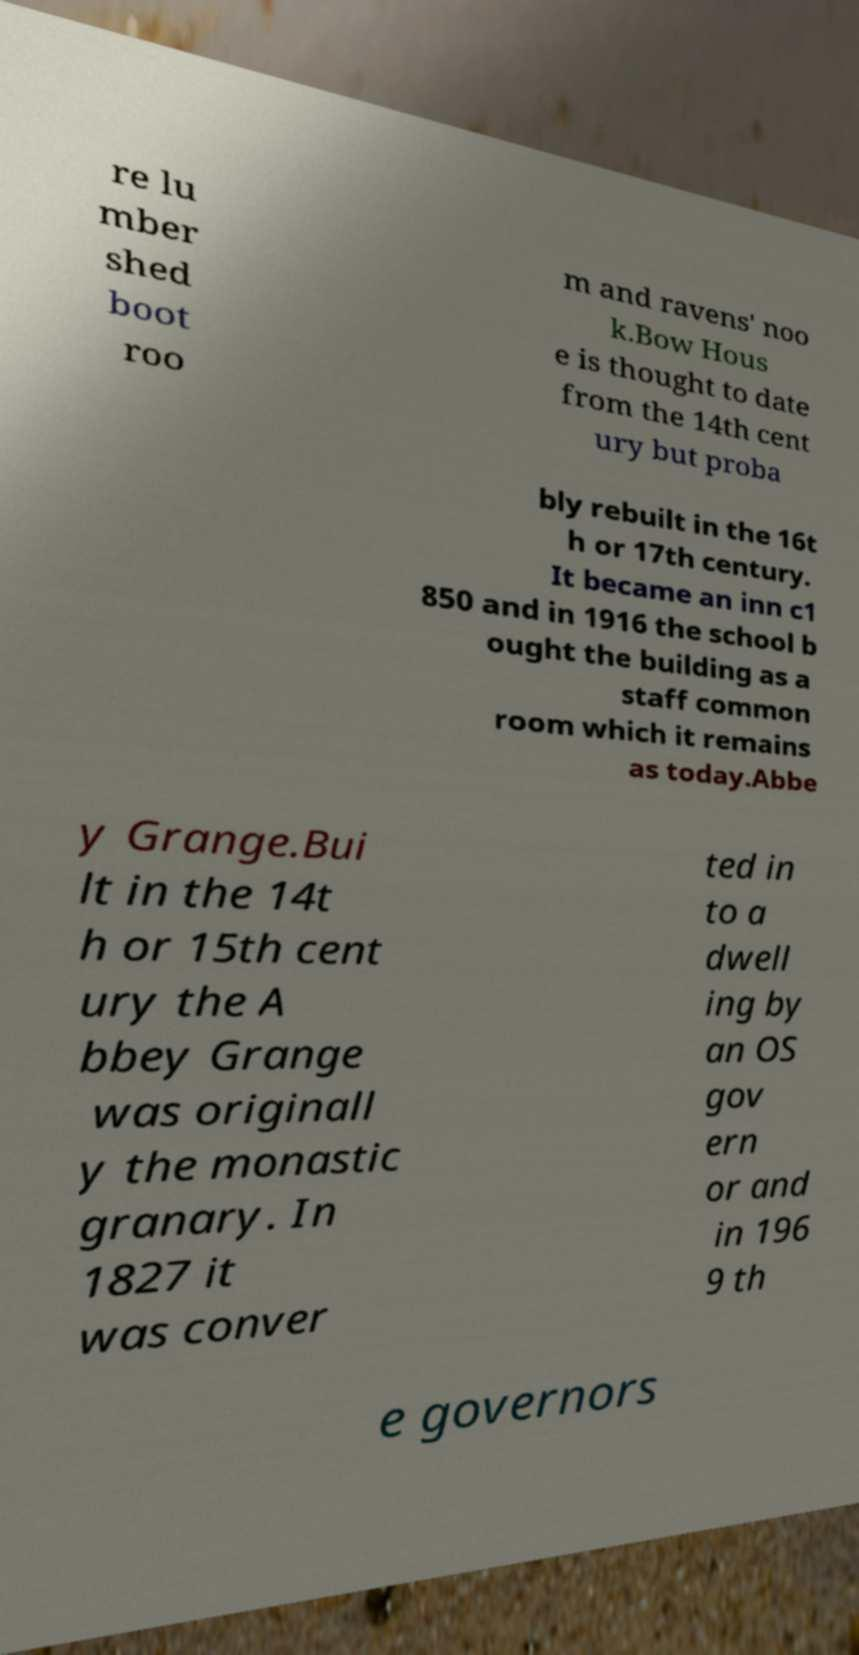What messages or text are displayed in this image? I need them in a readable, typed format. re lu mber shed boot roo m and ravens' noo k.Bow Hous e is thought to date from the 14th cent ury but proba bly rebuilt in the 16t h or 17th century. It became an inn c1 850 and in 1916 the school b ought the building as a staff common room which it remains as today.Abbe y Grange.Bui lt in the 14t h or 15th cent ury the A bbey Grange was originall y the monastic granary. In 1827 it was conver ted in to a dwell ing by an OS gov ern or and in 196 9 th e governors 